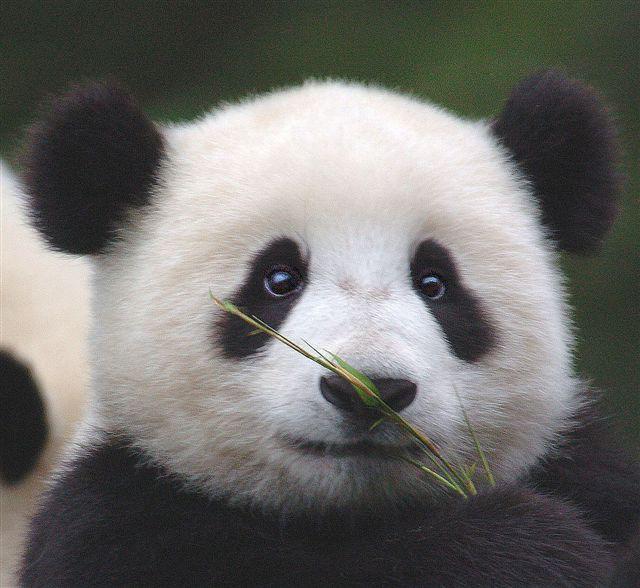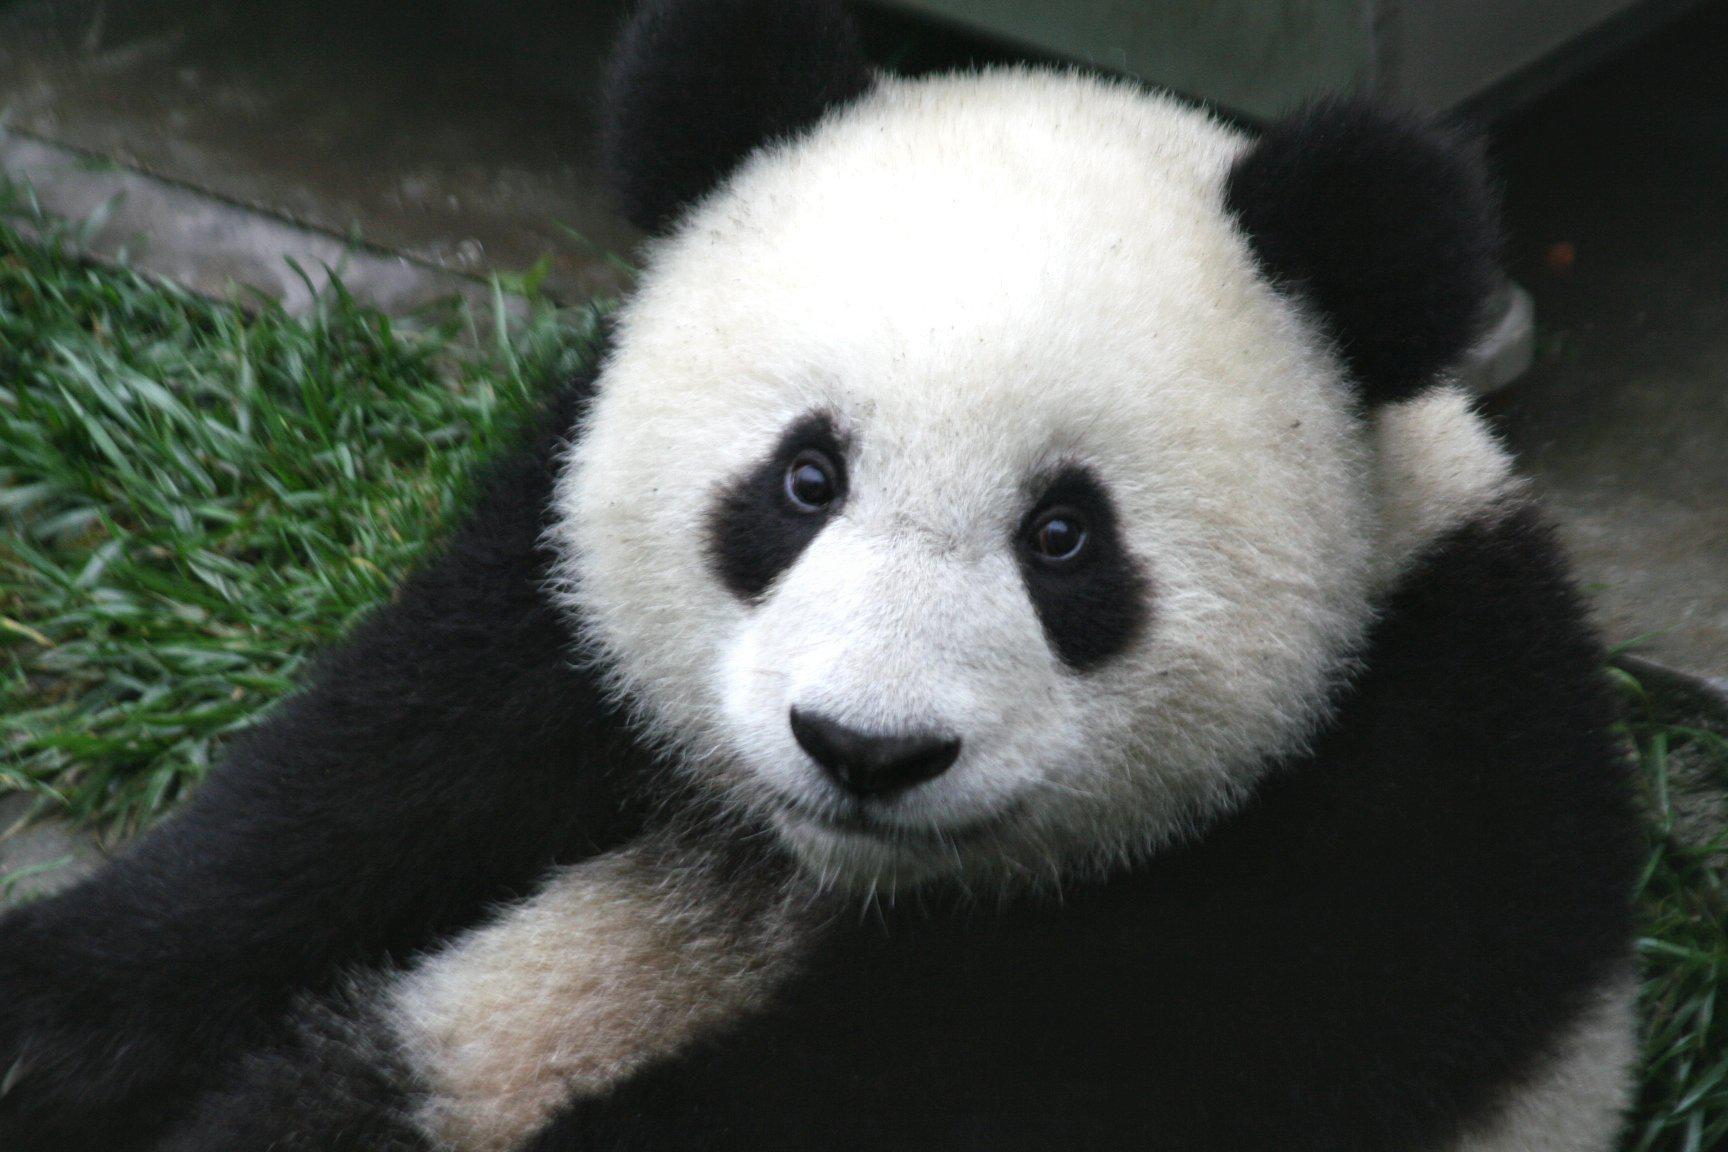The first image is the image on the left, the second image is the image on the right. Analyze the images presented: Is the assertion "A panda has its chin on a surface." valid? Answer yes or no. No. 